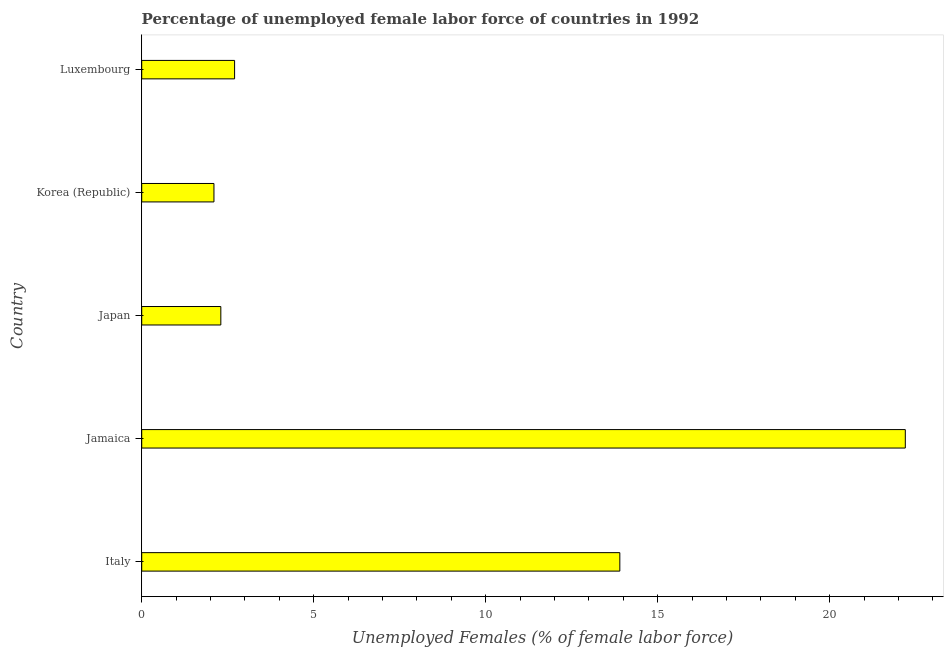What is the title of the graph?
Your answer should be compact. Percentage of unemployed female labor force of countries in 1992. What is the label or title of the X-axis?
Ensure brevity in your answer.  Unemployed Females (% of female labor force). What is the total unemployed female labour force in Japan?
Offer a terse response. 2.3. Across all countries, what is the maximum total unemployed female labour force?
Give a very brief answer. 22.2. Across all countries, what is the minimum total unemployed female labour force?
Keep it short and to the point. 2.1. In which country was the total unemployed female labour force maximum?
Provide a succinct answer. Jamaica. What is the sum of the total unemployed female labour force?
Offer a terse response. 43.2. What is the average total unemployed female labour force per country?
Give a very brief answer. 8.64. What is the median total unemployed female labour force?
Your answer should be compact. 2.7. What is the ratio of the total unemployed female labour force in Jamaica to that in Korea (Republic)?
Give a very brief answer. 10.57. Is the difference between the total unemployed female labour force in Jamaica and Korea (Republic) greater than the difference between any two countries?
Make the answer very short. Yes. Is the sum of the total unemployed female labour force in Jamaica and Japan greater than the maximum total unemployed female labour force across all countries?
Provide a succinct answer. Yes. What is the difference between the highest and the lowest total unemployed female labour force?
Offer a terse response. 20.1. In how many countries, is the total unemployed female labour force greater than the average total unemployed female labour force taken over all countries?
Make the answer very short. 2. How many bars are there?
Ensure brevity in your answer.  5. Are all the bars in the graph horizontal?
Provide a succinct answer. Yes. What is the Unemployed Females (% of female labor force) of Italy?
Your response must be concise. 13.9. What is the Unemployed Females (% of female labor force) in Jamaica?
Offer a very short reply. 22.2. What is the Unemployed Females (% of female labor force) in Japan?
Your answer should be very brief. 2.3. What is the Unemployed Females (% of female labor force) of Korea (Republic)?
Ensure brevity in your answer.  2.1. What is the Unemployed Females (% of female labor force) of Luxembourg?
Give a very brief answer. 2.7. What is the difference between the Unemployed Females (% of female labor force) in Italy and Jamaica?
Your answer should be very brief. -8.3. What is the difference between the Unemployed Females (% of female labor force) in Jamaica and Korea (Republic)?
Your response must be concise. 20.1. What is the difference between the Unemployed Females (% of female labor force) in Japan and Korea (Republic)?
Provide a short and direct response. 0.2. What is the ratio of the Unemployed Females (% of female labor force) in Italy to that in Jamaica?
Offer a terse response. 0.63. What is the ratio of the Unemployed Females (% of female labor force) in Italy to that in Japan?
Offer a very short reply. 6.04. What is the ratio of the Unemployed Females (% of female labor force) in Italy to that in Korea (Republic)?
Offer a very short reply. 6.62. What is the ratio of the Unemployed Females (% of female labor force) in Italy to that in Luxembourg?
Your answer should be very brief. 5.15. What is the ratio of the Unemployed Females (% of female labor force) in Jamaica to that in Japan?
Provide a short and direct response. 9.65. What is the ratio of the Unemployed Females (% of female labor force) in Jamaica to that in Korea (Republic)?
Offer a very short reply. 10.57. What is the ratio of the Unemployed Females (% of female labor force) in Jamaica to that in Luxembourg?
Provide a succinct answer. 8.22. What is the ratio of the Unemployed Females (% of female labor force) in Japan to that in Korea (Republic)?
Give a very brief answer. 1.09. What is the ratio of the Unemployed Females (% of female labor force) in Japan to that in Luxembourg?
Give a very brief answer. 0.85. What is the ratio of the Unemployed Females (% of female labor force) in Korea (Republic) to that in Luxembourg?
Keep it short and to the point. 0.78. 